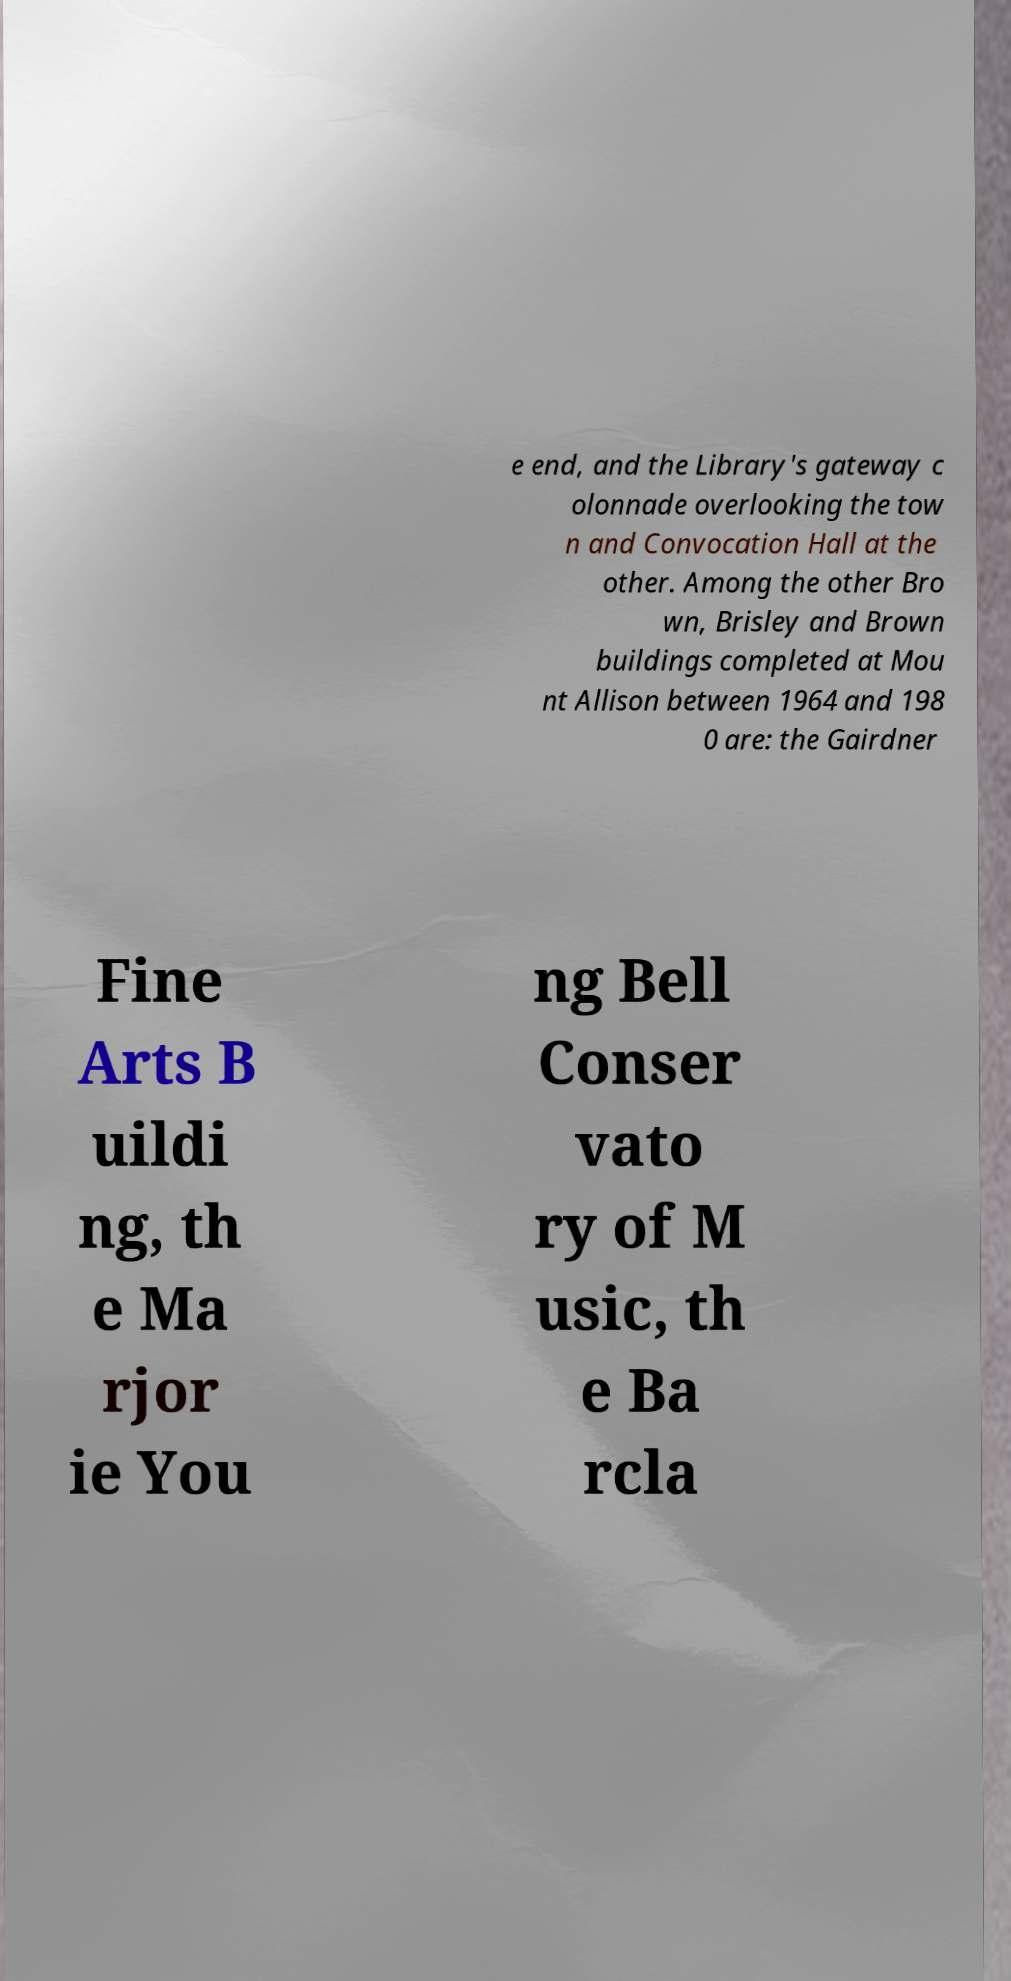What messages or text are displayed in this image? I need them in a readable, typed format. e end, and the Library's gateway c olonnade overlooking the tow n and Convocation Hall at the other. Among the other Bro wn, Brisley and Brown buildings completed at Mou nt Allison between 1964 and 198 0 are: the Gairdner Fine Arts B uildi ng, th e Ma rjor ie You ng Bell Conser vato ry of M usic, th e Ba rcla 